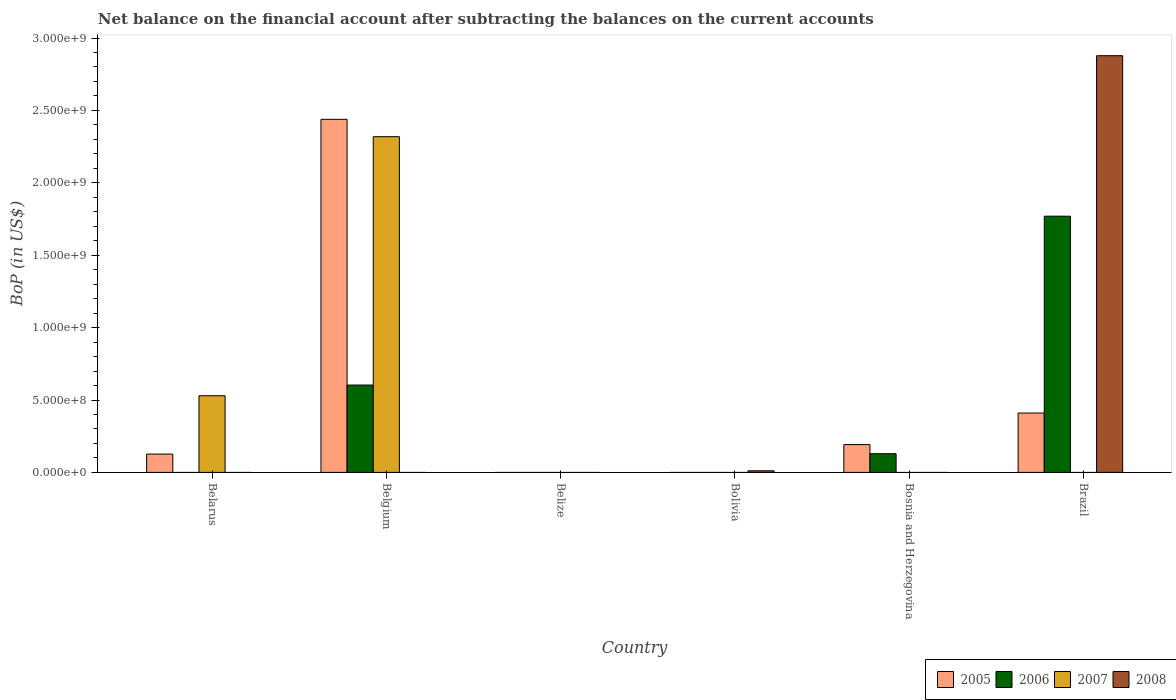Are the number of bars per tick equal to the number of legend labels?
Ensure brevity in your answer.  No. What is the label of the 1st group of bars from the left?
Your answer should be compact. Belarus. In how many cases, is the number of bars for a given country not equal to the number of legend labels?
Keep it short and to the point. 6. What is the Balance of Payments in 2008 in Bolivia?
Offer a very short reply. 1.10e+07. Across all countries, what is the maximum Balance of Payments in 2007?
Offer a very short reply. 2.32e+09. Across all countries, what is the minimum Balance of Payments in 2008?
Give a very brief answer. 0. What is the total Balance of Payments in 2005 in the graph?
Offer a terse response. 3.17e+09. What is the difference between the Balance of Payments in 2005 in Belarus and that in Bosnia and Herzegovina?
Ensure brevity in your answer.  -6.55e+07. What is the difference between the Balance of Payments in 2005 in Belarus and the Balance of Payments in 2006 in Brazil?
Provide a short and direct response. -1.64e+09. What is the average Balance of Payments in 2008 per country?
Offer a terse response. 4.81e+08. What is the difference between the Balance of Payments of/in 2006 and Balance of Payments of/in 2007 in Belgium?
Your response must be concise. -1.72e+09. What is the ratio of the Balance of Payments in 2005 in Belarus to that in Belgium?
Make the answer very short. 0.05. What is the difference between the highest and the second highest Balance of Payments in 2006?
Offer a terse response. -1.17e+09. What is the difference between the highest and the lowest Balance of Payments in 2005?
Offer a very short reply. 2.44e+09. Is the sum of the Balance of Payments in 2005 in Bosnia and Herzegovina and Brazil greater than the maximum Balance of Payments in 2008 across all countries?
Your answer should be compact. No. How many bars are there?
Provide a short and direct response. 11. How many countries are there in the graph?
Your answer should be compact. 6. What is the difference between two consecutive major ticks on the Y-axis?
Your answer should be very brief. 5.00e+08. How are the legend labels stacked?
Ensure brevity in your answer.  Horizontal. What is the title of the graph?
Provide a short and direct response. Net balance on the financial account after subtracting the balances on the current accounts. What is the label or title of the X-axis?
Ensure brevity in your answer.  Country. What is the label or title of the Y-axis?
Your answer should be compact. BoP (in US$). What is the BoP (in US$) of 2005 in Belarus?
Offer a very short reply. 1.27e+08. What is the BoP (in US$) of 2007 in Belarus?
Provide a short and direct response. 5.29e+08. What is the BoP (in US$) of 2005 in Belgium?
Provide a succinct answer. 2.44e+09. What is the BoP (in US$) in 2006 in Belgium?
Offer a terse response. 6.03e+08. What is the BoP (in US$) of 2007 in Belgium?
Your answer should be very brief. 2.32e+09. What is the BoP (in US$) of 2008 in Belgium?
Provide a succinct answer. 0. What is the BoP (in US$) of 2008 in Belize?
Provide a short and direct response. 0. What is the BoP (in US$) of 2006 in Bolivia?
Ensure brevity in your answer.  0. What is the BoP (in US$) of 2007 in Bolivia?
Your answer should be very brief. 0. What is the BoP (in US$) in 2008 in Bolivia?
Ensure brevity in your answer.  1.10e+07. What is the BoP (in US$) in 2005 in Bosnia and Herzegovina?
Your answer should be compact. 1.92e+08. What is the BoP (in US$) in 2006 in Bosnia and Herzegovina?
Make the answer very short. 1.29e+08. What is the BoP (in US$) in 2008 in Bosnia and Herzegovina?
Ensure brevity in your answer.  0. What is the BoP (in US$) in 2005 in Brazil?
Offer a terse response. 4.10e+08. What is the BoP (in US$) in 2006 in Brazil?
Keep it short and to the point. 1.77e+09. What is the BoP (in US$) of 2007 in Brazil?
Your answer should be very brief. 0. What is the BoP (in US$) in 2008 in Brazil?
Provide a short and direct response. 2.88e+09. Across all countries, what is the maximum BoP (in US$) of 2005?
Offer a terse response. 2.44e+09. Across all countries, what is the maximum BoP (in US$) in 2006?
Your response must be concise. 1.77e+09. Across all countries, what is the maximum BoP (in US$) in 2007?
Offer a terse response. 2.32e+09. Across all countries, what is the maximum BoP (in US$) in 2008?
Make the answer very short. 2.88e+09. Across all countries, what is the minimum BoP (in US$) of 2006?
Your answer should be compact. 0. Across all countries, what is the minimum BoP (in US$) of 2008?
Your answer should be compact. 0. What is the total BoP (in US$) of 2005 in the graph?
Ensure brevity in your answer.  3.17e+09. What is the total BoP (in US$) in 2006 in the graph?
Your response must be concise. 2.50e+09. What is the total BoP (in US$) of 2007 in the graph?
Make the answer very short. 2.85e+09. What is the total BoP (in US$) in 2008 in the graph?
Your response must be concise. 2.89e+09. What is the difference between the BoP (in US$) of 2005 in Belarus and that in Belgium?
Provide a short and direct response. -2.31e+09. What is the difference between the BoP (in US$) in 2007 in Belarus and that in Belgium?
Your answer should be very brief. -1.79e+09. What is the difference between the BoP (in US$) of 2005 in Belarus and that in Bosnia and Herzegovina?
Your response must be concise. -6.55e+07. What is the difference between the BoP (in US$) of 2005 in Belarus and that in Brazil?
Ensure brevity in your answer.  -2.83e+08. What is the difference between the BoP (in US$) in 2005 in Belgium and that in Bosnia and Herzegovina?
Your answer should be compact. 2.25e+09. What is the difference between the BoP (in US$) of 2006 in Belgium and that in Bosnia and Herzegovina?
Your answer should be compact. 4.74e+08. What is the difference between the BoP (in US$) of 2005 in Belgium and that in Brazil?
Ensure brevity in your answer.  2.03e+09. What is the difference between the BoP (in US$) of 2006 in Belgium and that in Brazil?
Your answer should be compact. -1.17e+09. What is the difference between the BoP (in US$) in 2008 in Bolivia and that in Brazil?
Provide a succinct answer. -2.87e+09. What is the difference between the BoP (in US$) in 2005 in Bosnia and Herzegovina and that in Brazil?
Your answer should be compact. -2.18e+08. What is the difference between the BoP (in US$) in 2006 in Bosnia and Herzegovina and that in Brazil?
Make the answer very short. -1.64e+09. What is the difference between the BoP (in US$) in 2005 in Belarus and the BoP (in US$) in 2006 in Belgium?
Provide a succinct answer. -4.77e+08. What is the difference between the BoP (in US$) of 2005 in Belarus and the BoP (in US$) of 2007 in Belgium?
Offer a terse response. -2.19e+09. What is the difference between the BoP (in US$) of 2005 in Belarus and the BoP (in US$) of 2008 in Bolivia?
Offer a terse response. 1.16e+08. What is the difference between the BoP (in US$) of 2007 in Belarus and the BoP (in US$) of 2008 in Bolivia?
Provide a short and direct response. 5.18e+08. What is the difference between the BoP (in US$) in 2005 in Belarus and the BoP (in US$) in 2006 in Bosnia and Herzegovina?
Your answer should be very brief. -2.43e+06. What is the difference between the BoP (in US$) in 2005 in Belarus and the BoP (in US$) in 2006 in Brazil?
Give a very brief answer. -1.64e+09. What is the difference between the BoP (in US$) of 2005 in Belarus and the BoP (in US$) of 2008 in Brazil?
Your response must be concise. -2.75e+09. What is the difference between the BoP (in US$) in 2007 in Belarus and the BoP (in US$) in 2008 in Brazil?
Your response must be concise. -2.35e+09. What is the difference between the BoP (in US$) of 2005 in Belgium and the BoP (in US$) of 2008 in Bolivia?
Your answer should be very brief. 2.43e+09. What is the difference between the BoP (in US$) of 2006 in Belgium and the BoP (in US$) of 2008 in Bolivia?
Give a very brief answer. 5.92e+08. What is the difference between the BoP (in US$) in 2007 in Belgium and the BoP (in US$) in 2008 in Bolivia?
Offer a very short reply. 2.31e+09. What is the difference between the BoP (in US$) of 2005 in Belgium and the BoP (in US$) of 2006 in Bosnia and Herzegovina?
Provide a short and direct response. 2.31e+09. What is the difference between the BoP (in US$) in 2005 in Belgium and the BoP (in US$) in 2006 in Brazil?
Provide a succinct answer. 6.69e+08. What is the difference between the BoP (in US$) of 2005 in Belgium and the BoP (in US$) of 2008 in Brazil?
Give a very brief answer. -4.39e+08. What is the difference between the BoP (in US$) of 2006 in Belgium and the BoP (in US$) of 2008 in Brazil?
Offer a terse response. -2.27e+09. What is the difference between the BoP (in US$) in 2007 in Belgium and the BoP (in US$) in 2008 in Brazil?
Make the answer very short. -5.59e+08. What is the difference between the BoP (in US$) in 2005 in Bosnia and Herzegovina and the BoP (in US$) in 2006 in Brazil?
Give a very brief answer. -1.58e+09. What is the difference between the BoP (in US$) in 2005 in Bosnia and Herzegovina and the BoP (in US$) in 2008 in Brazil?
Your answer should be very brief. -2.69e+09. What is the difference between the BoP (in US$) in 2006 in Bosnia and Herzegovina and the BoP (in US$) in 2008 in Brazil?
Ensure brevity in your answer.  -2.75e+09. What is the average BoP (in US$) in 2005 per country?
Your answer should be compact. 5.28e+08. What is the average BoP (in US$) of 2006 per country?
Provide a succinct answer. 4.17e+08. What is the average BoP (in US$) in 2007 per country?
Provide a succinct answer. 4.75e+08. What is the average BoP (in US$) of 2008 per country?
Your answer should be compact. 4.81e+08. What is the difference between the BoP (in US$) in 2005 and BoP (in US$) in 2007 in Belarus?
Ensure brevity in your answer.  -4.03e+08. What is the difference between the BoP (in US$) in 2005 and BoP (in US$) in 2006 in Belgium?
Your answer should be very brief. 1.84e+09. What is the difference between the BoP (in US$) in 2005 and BoP (in US$) in 2007 in Belgium?
Offer a very short reply. 1.20e+08. What is the difference between the BoP (in US$) in 2006 and BoP (in US$) in 2007 in Belgium?
Offer a very short reply. -1.72e+09. What is the difference between the BoP (in US$) in 2005 and BoP (in US$) in 2006 in Bosnia and Herzegovina?
Your answer should be compact. 6.31e+07. What is the difference between the BoP (in US$) in 2005 and BoP (in US$) in 2006 in Brazil?
Provide a succinct answer. -1.36e+09. What is the difference between the BoP (in US$) of 2005 and BoP (in US$) of 2008 in Brazil?
Make the answer very short. -2.47e+09. What is the difference between the BoP (in US$) of 2006 and BoP (in US$) of 2008 in Brazil?
Provide a short and direct response. -1.11e+09. What is the ratio of the BoP (in US$) of 2005 in Belarus to that in Belgium?
Keep it short and to the point. 0.05. What is the ratio of the BoP (in US$) of 2007 in Belarus to that in Belgium?
Keep it short and to the point. 0.23. What is the ratio of the BoP (in US$) in 2005 in Belarus to that in Bosnia and Herzegovina?
Your answer should be compact. 0.66. What is the ratio of the BoP (in US$) in 2005 in Belarus to that in Brazil?
Your response must be concise. 0.31. What is the ratio of the BoP (in US$) of 2005 in Belgium to that in Bosnia and Herzegovina?
Offer a terse response. 12.69. What is the ratio of the BoP (in US$) in 2006 in Belgium to that in Bosnia and Herzegovina?
Your response must be concise. 4.67. What is the ratio of the BoP (in US$) in 2005 in Belgium to that in Brazil?
Offer a terse response. 5.95. What is the ratio of the BoP (in US$) in 2006 in Belgium to that in Brazil?
Your answer should be compact. 0.34. What is the ratio of the BoP (in US$) of 2008 in Bolivia to that in Brazil?
Ensure brevity in your answer.  0. What is the ratio of the BoP (in US$) of 2005 in Bosnia and Herzegovina to that in Brazil?
Give a very brief answer. 0.47. What is the ratio of the BoP (in US$) of 2006 in Bosnia and Herzegovina to that in Brazil?
Provide a succinct answer. 0.07. What is the difference between the highest and the second highest BoP (in US$) of 2005?
Offer a very short reply. 2.03e+09. What is the difference between the highest and the second highest BoP (in US$) in 2006?
Ensure brevity in your answer.  1.17e+09. What is the difference between the highest and the lowest BoP (in US$) in 2005?
Give a very brief answer. 2.44e+09. What is the difference between the highest and the lowest BoP (in US$) in 2006?
Offer a very short reply. 1.77e+09. What is the difference between the highest and the lowest BoP (in US$) in 2007?
Your response must be concise. 2.32e+09. What is the difference between the highest and the lowest BoP (in US$) of 2008?
Offer a terse response. 2.88e+09. 